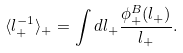Convert formula to latex. <formula><loc_0><loc_0><loc_500><loc_500>\langle l _ { + } ^ { - 1 } \rangle _ { + } = \int d l _ { + } \frac { \phi ^ { B } _ { + } ( l _ { + } ) } { l _ { + } } .</formula> 